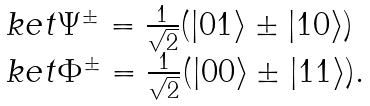<formula> <loc_0><loc_0><loc_500><loc_500>\begin{array} { l } \ k e t { \Psi ^ { \pm } } = \frac { 1 } { \sqrt { 2 } } ( | 0 1 \rangle \pm | 1 0 \rangle ) \\ \ k e t { \Phi ^ { \pm } } = \frac { 1 } { \sqrt { 2 } } ( | 0 0 \rangle \pm | 1 1 \rangle ) . \end{array}</formula> 